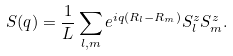<formula> <loc_0><loc_0><loc_500><loc_500>S ( q ) = \frac { 1 } { L } \sum _ { l , m } e ^ { i q ( R _ { l } - R _ { m } ) } S _ { l } ^ { z } S _ { m } ^ { z } .</formula> 